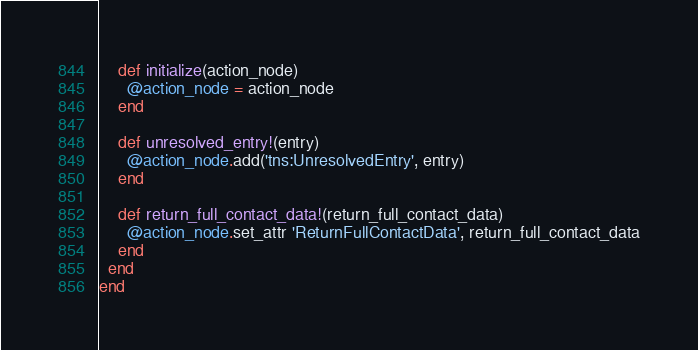<code> <loc_0><loc_0><loc_500><loc_500><_Ruby_>    def initialize(action_node)
      @action_node = action_node
    end

    def unresolved_entry!(entry)
      @action_node.add('tns:UnresolvedEntry', entry)
    end

    def return_full_contact_data!(return_full_contact_data)
      @action_node.set_attr 'ReturnFullContactData', return_full_contact_data
    end    
  end
end
</code> 